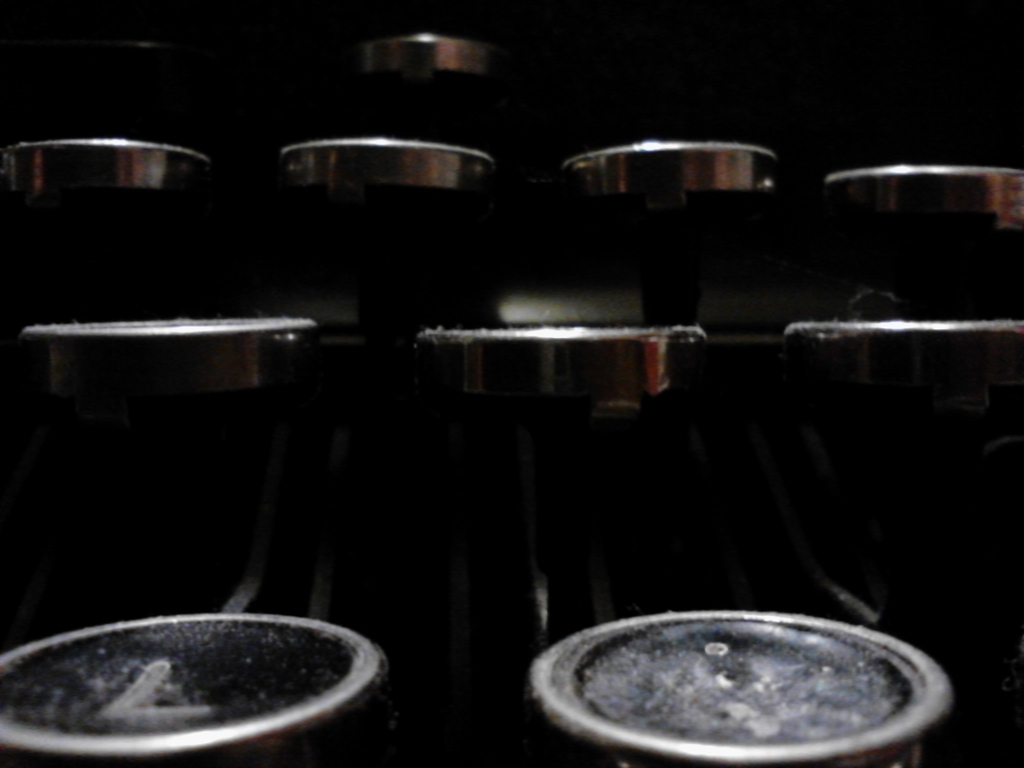Are the objects in the image new or do they look used, and what can that tell us about their environment? The visible dust and slight wear on the objects suggest that they are not new and have been used over time. This could imply that the equipment is well-loved and regularly utilized, possibly in a professional setting where it is important to maintain the integrity of complex and potentially delicate systems. 